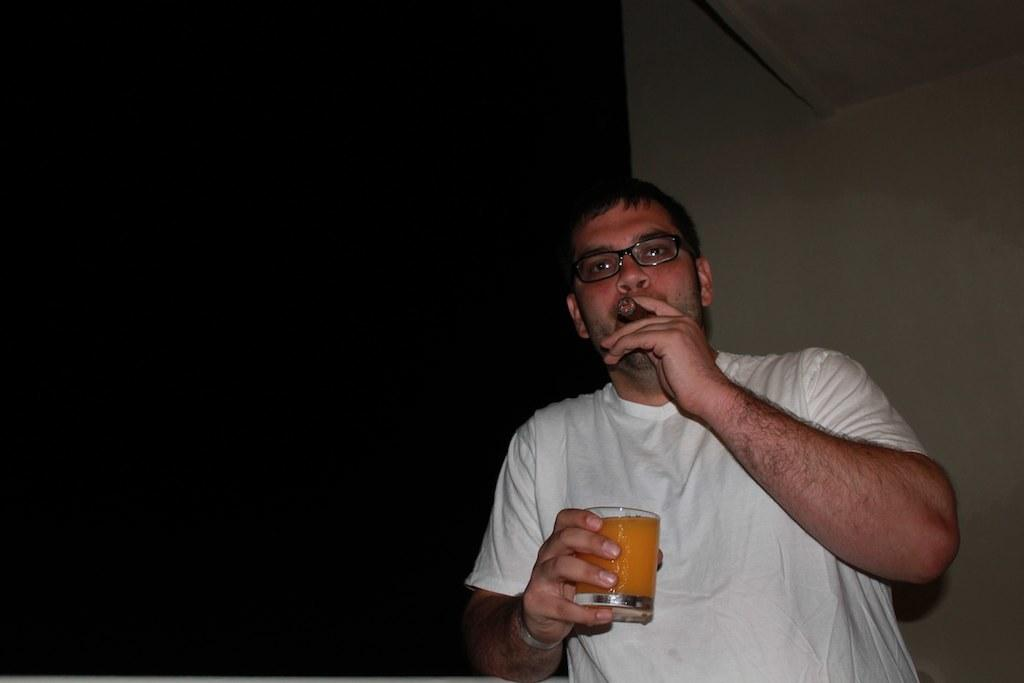What is the main subject of the image? There is a person in the image. What is the person holding in their right hand? The person is holding a glass in their right hand. What is the person holding in their left hand? The person is holding a cigar in their left hand. What is the person wearing on their upper body? The person is wearing a white t-shirt. What type of eyewear does the person have? The person has spectacles. How many apples can be seen in the wilderness in the image? There are no apples or wilderness present in the image; it features a person holding a glass and a cigar while wearing a white t-shirt and spectacles. 